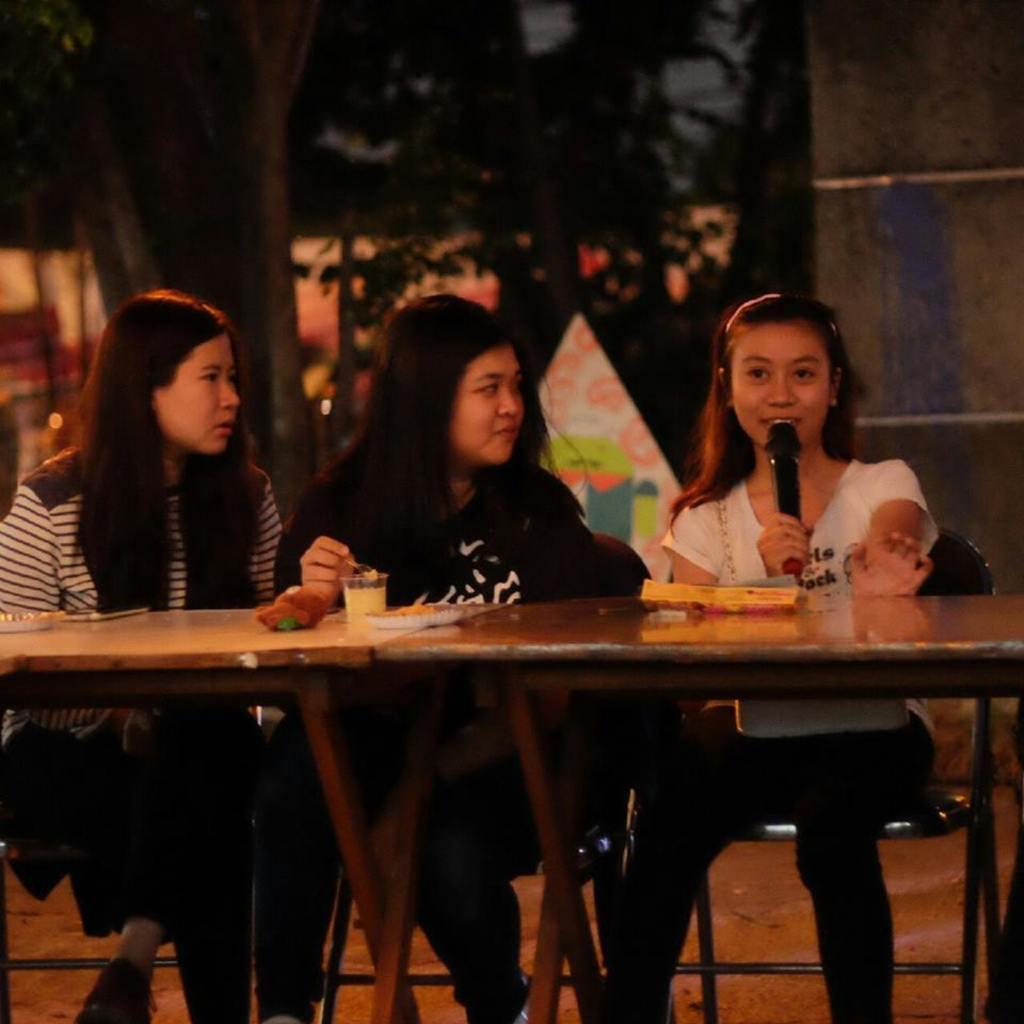Please provide a concise description of this image. On the background we can see trees. Here we can see three women sitting on chairs in front of a table and on the table we can see plate of food, juice in a glass, a box. This woman is talking in a mic. 